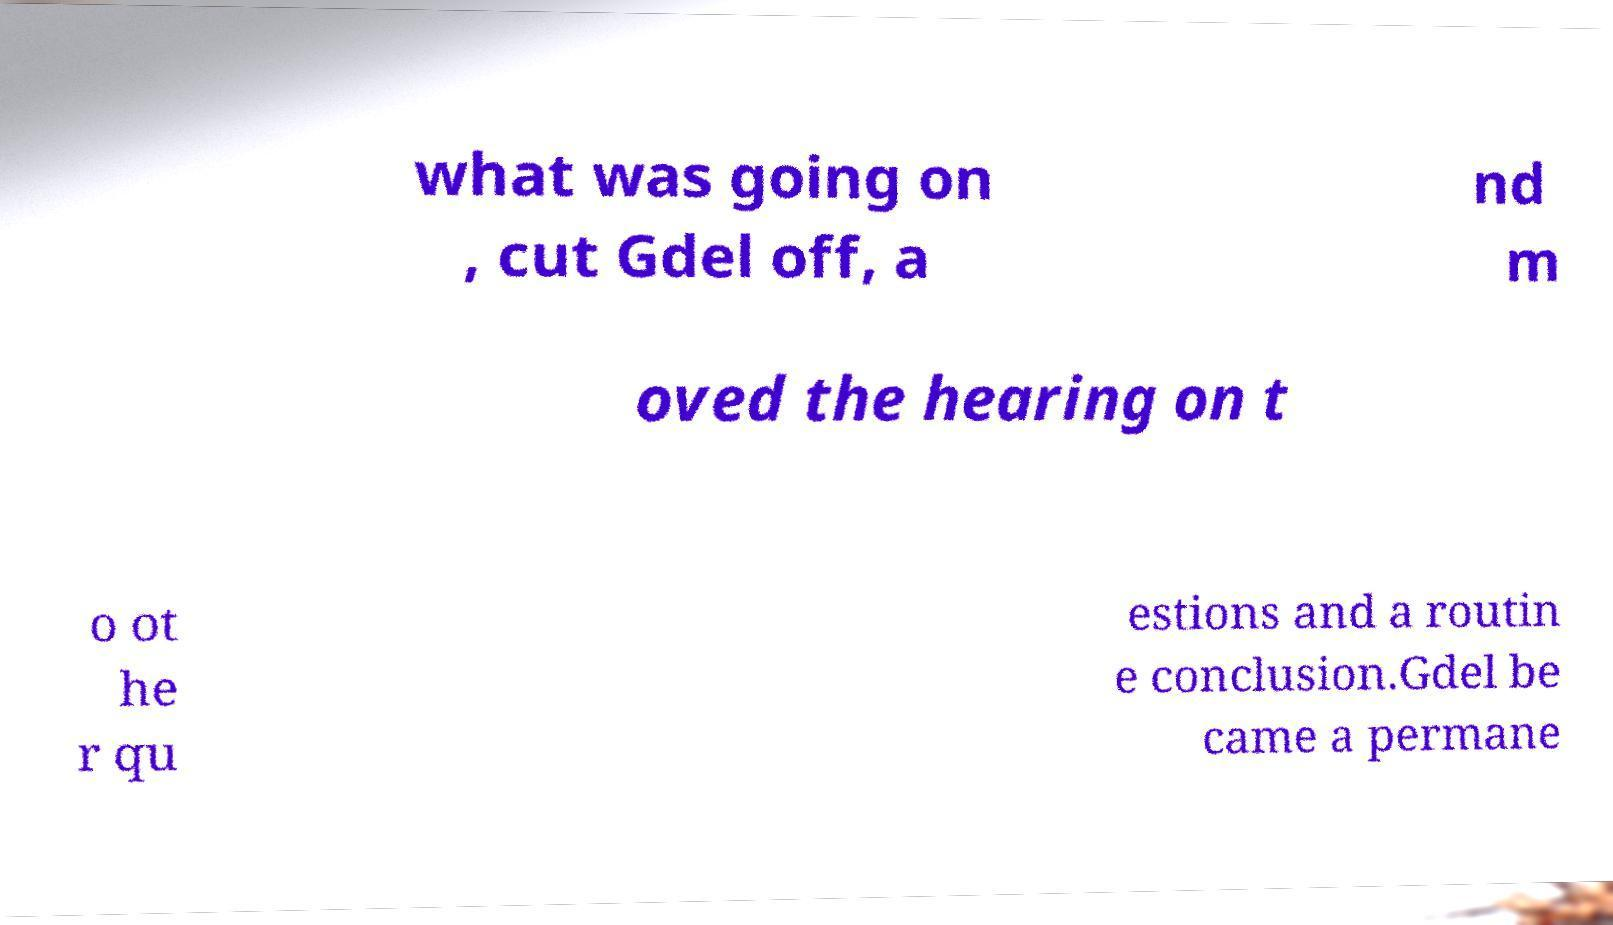Could you extract and type out the text from this image? what was going on , cut Gdel off, a nd m oved the hearing on t o ot he r qu estions and a routin e conclusion.Gdel be came a permane 